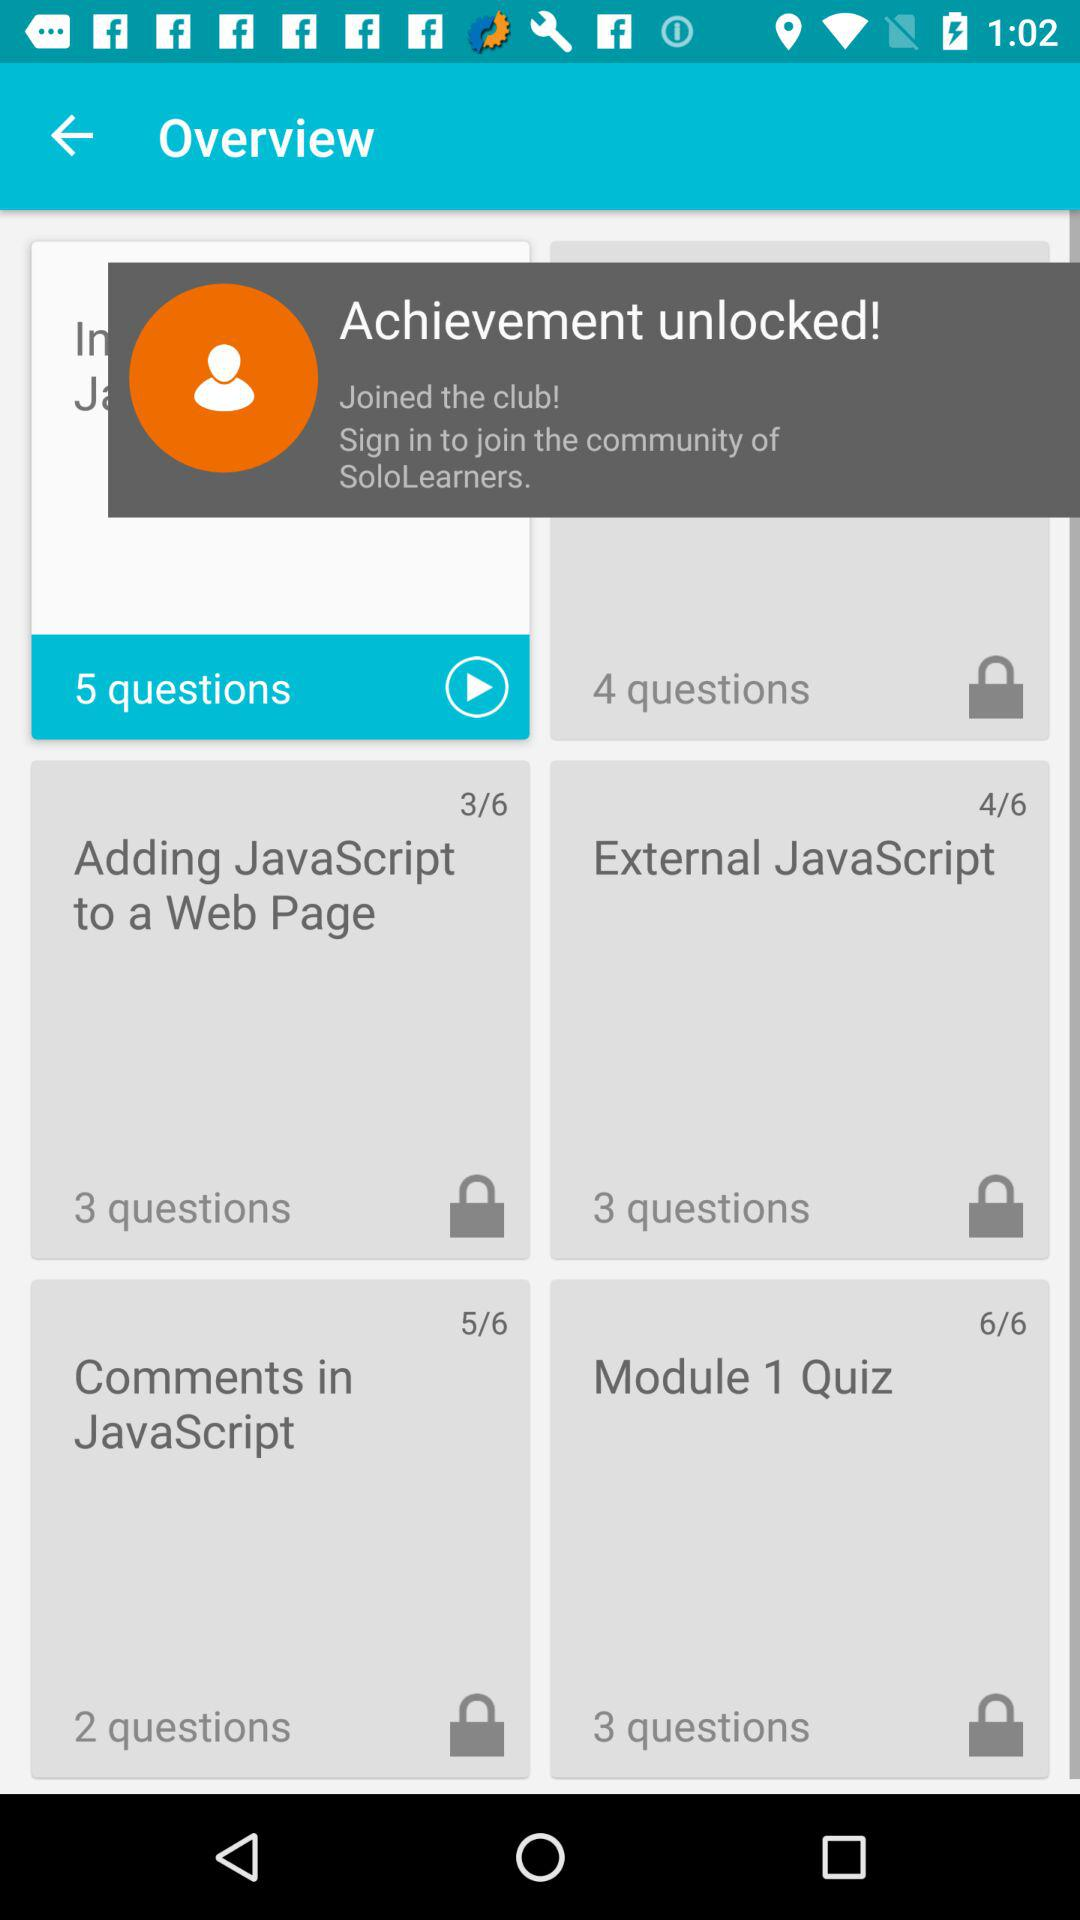How many questions are there in "External JavaScript"? There are 3 questions in "External JavaScript". 